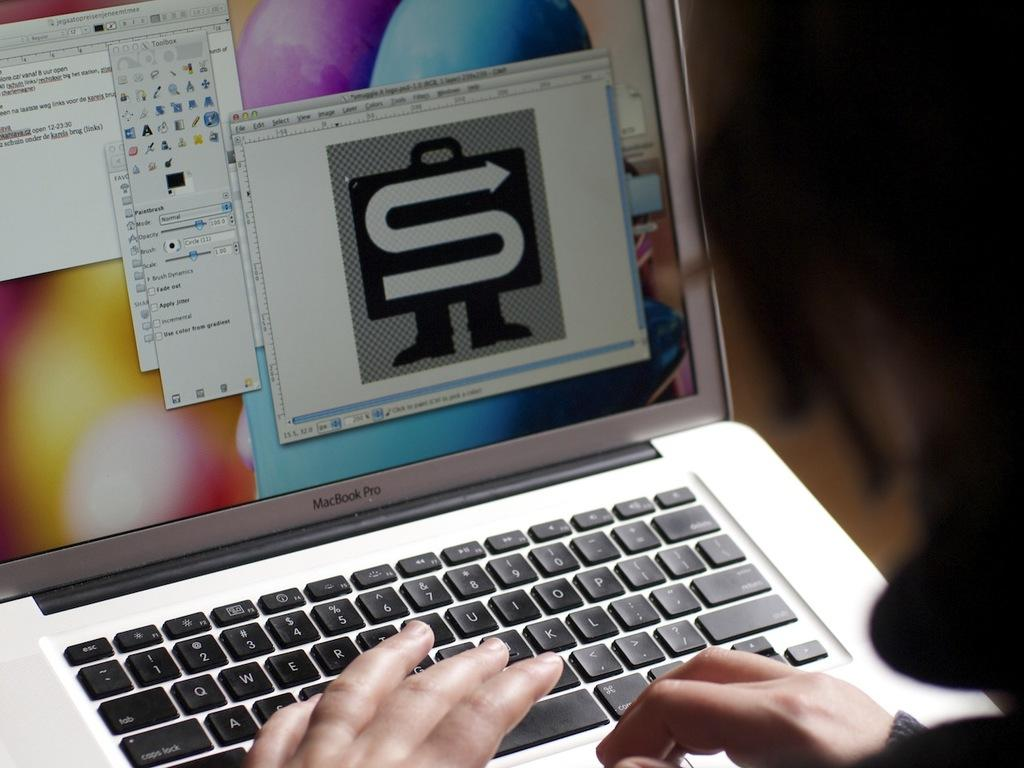<image>
Give a short and clear explanation of the subsequent image. A monitor with a large S on one of the applications. 